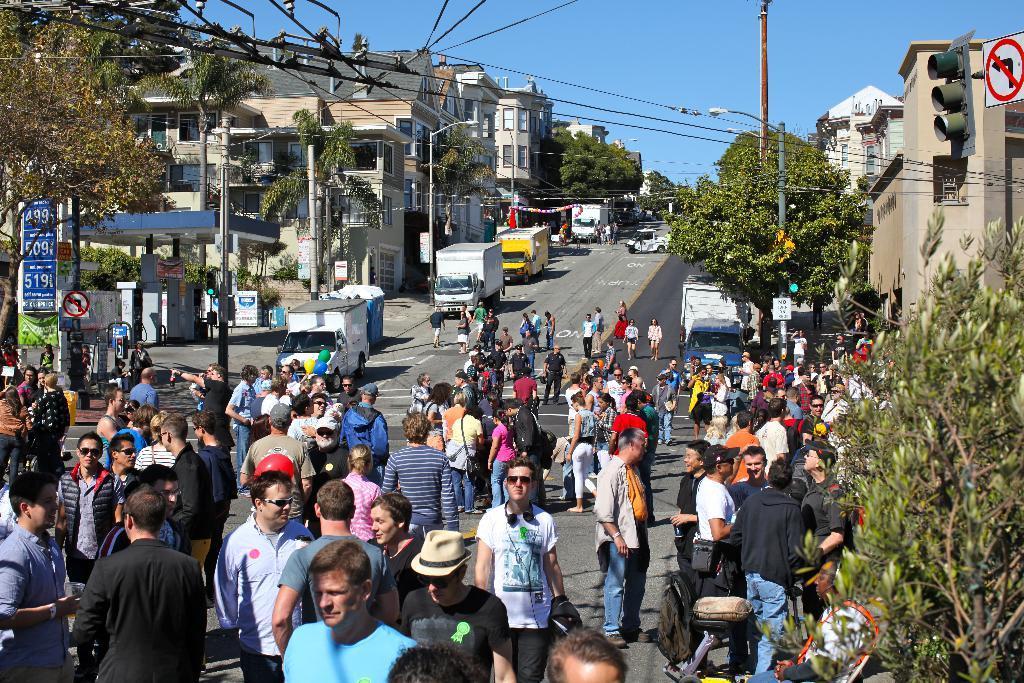Please provide a concise description of this image. Here we can see crowd and there are vehicles on the road. Here we can see poles, trees, boards, lights, traffic signals, and buildings. In the background there is sky. 